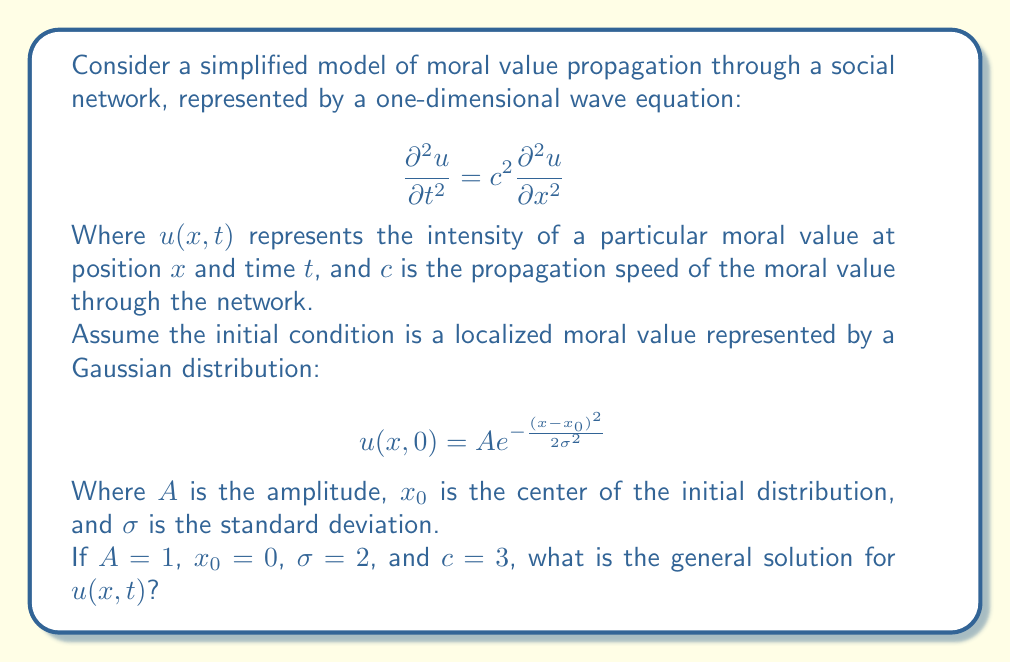What is the answer to this math problem? To solve this problem, we need to apply the solution method for the one-dimensional wave equation with an initial condition. The general solution for the wave equation is given by d'Alembert's formula:

$$ u(x,t) = \frac{1}{2}[f(x-ct) + f(x+ct)] + \frac{1}{2c}\int_{x-ct}^{x+ct} g(s) ds $$

Where $f(x)$ is the initial displacement and $g(x)$ is the initial velocity.

In this case, we have:

$$ f(x) = u(x,0) = e^{-\frac{x^2}{8}} $$

And we assume $g(x) = 0$ (no initial velocity).

Substituting these into d'Alembert's formula:

$$ u(x,t) = \frac{1}{2}[e^{-\frac{(x-ct)^2}{8}} + e^{-\frac{(x+ct)^2}{8}}] $$

This solution represents two waves moving in opposite directions, each maintaining the shape of the initial Gaussian distribution.

To verify that this solution satisfies the wave equation, we can differentiate:

$$ \frac{\partial u}{\partial t} = \frac{c}{8}[(x-ct)e^{-\frac{(x-ct)^2}{8}} - (x+ct)e^{-\frac{(x+ct)^2}{8}}] $$

$$ \frac{\partial^2 u}{\partial t^2} = \frac{c^2}{64}[(x-ct)^2e^{-\frac{(x-ct)^2}{8}} + (x+ct)^2e^{-\frac{(x+ct)^2}{8}} - 4e^{-\frac{(x-ct)^2}{8}} - 4e^{-\frac{(x+ct)^2}{8}}] $$

$$ \frac{\partial u}{\partial x} = -\frac{1}{8}[(x-ct)e^{-\frac{(x-ct)^2}{8}} + (x+ct)e^{-\frac{(x+ct)^2}{8}}] $$

$$ \frac{\partial^2 u}{\partial x^2} = \frac{1}{64}[(x-ct)^2e^{-\frac{(x-ct)^2}{8}} + (x+ct)^2e^{-\frac{(x+ct)^2}{8}} - 4e^{-\frac{(x-ct)^2}{8}} - 4e^{-\frac{(x+ct)^2}{8}}] $$

We can see that $\frac{\partial^2 u}{\partial t^2} = c^2 \frac{\partial^2 u}{\partial x^2}$, confirming that our solution satisfies the wave equation.
Answer: $$ u(x,t) = \frac{1}{2}[e^{-\frac{(x-3t)^2}{8}} + e^{-\frac{(x+3t)^2}{8}}] $$ 